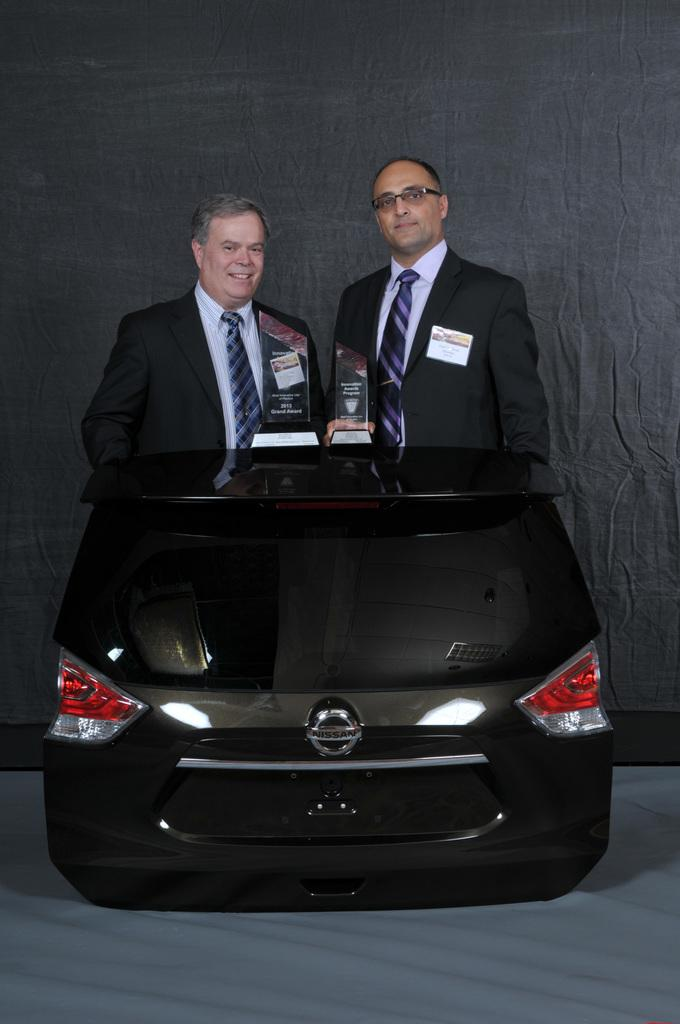How many people are in the image? There are two men in the image. What are the men doing in the image? The men are standing behind a car. What brand of car is in the image? The car has a Nissan brand. What are the men holding in their hands? The men are holding momentous in their hands. What type of apparel is the car wearing in the image? Cars do not wear apparel; the question is not applicable to the image. Where is the image taken, and what place is depicted? The location of the image is not mentioned in the provided facts, so it cannot be determined. 